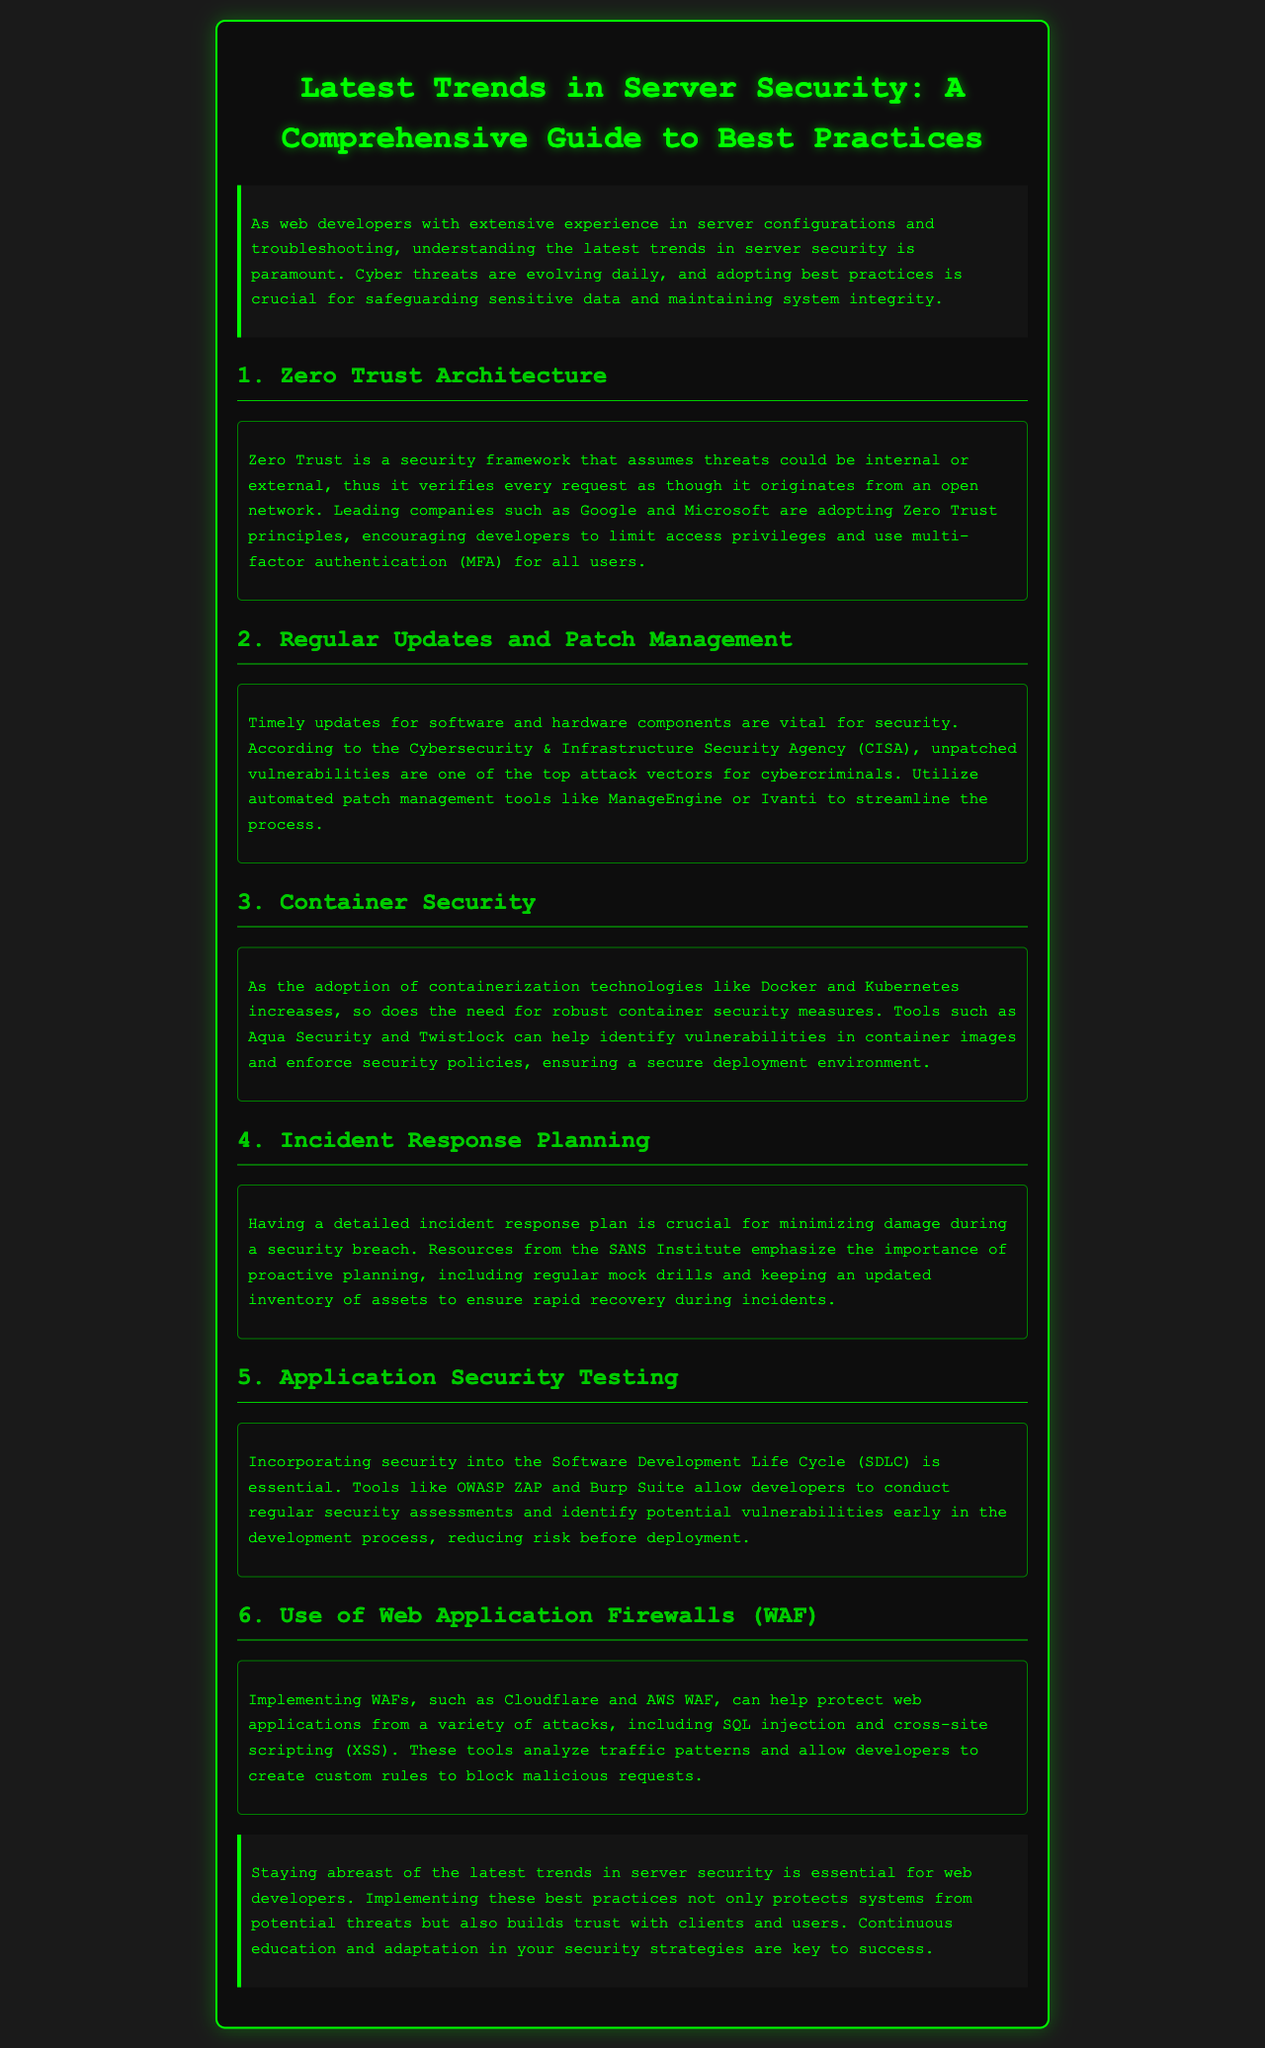What is the main focus of the newsletter? The newsletter emphasizes the importance of understanding the latest trends in server security for web developers.
Answer: Latest trends in server security Which security framework is recommended in the document? The document suggests implementing a security framework that verifies every request assuming threats could come from any source.
Answer: Zero Trust What type of authentication is encouraged for all users? The newsletter mentions a specific type of authentication that enhances security by requiring additional verification.
Answer: Multi-factor authentication (MFA) What are developers advised to use for automated patch management? The document lists specific tools aimed at simplifying the process of managing software updates.
Answer: ManageEngine or Ivanti What is essential to minimize damage during a security breach? The newsletter stresses having a particular plan in place to respond effectively to security incidents.
Answer: Incident response plan Which tools are recommended for security testing during the Software Development Life Cycle? The document mentions two specific tools that help in identifying vulnerabilities during development.
Answer: OWASP ZAP and Burp Suite What does WAF stand for? The newsletter refers to a specific type of security tool that protects web applications from attacks.
Answer: Web Application Firewall What is the purpose of conducting regular mock drills? The document emphasizes practicing a specific process to ensure preparedness in case of security incidents.
Answer: Incident response planning What are examples of container security tools mentioned? The newsletter refers to specific tools that help secure containerized environments, enhancing overall security.
Answer: Aqua Security and Twistlock 